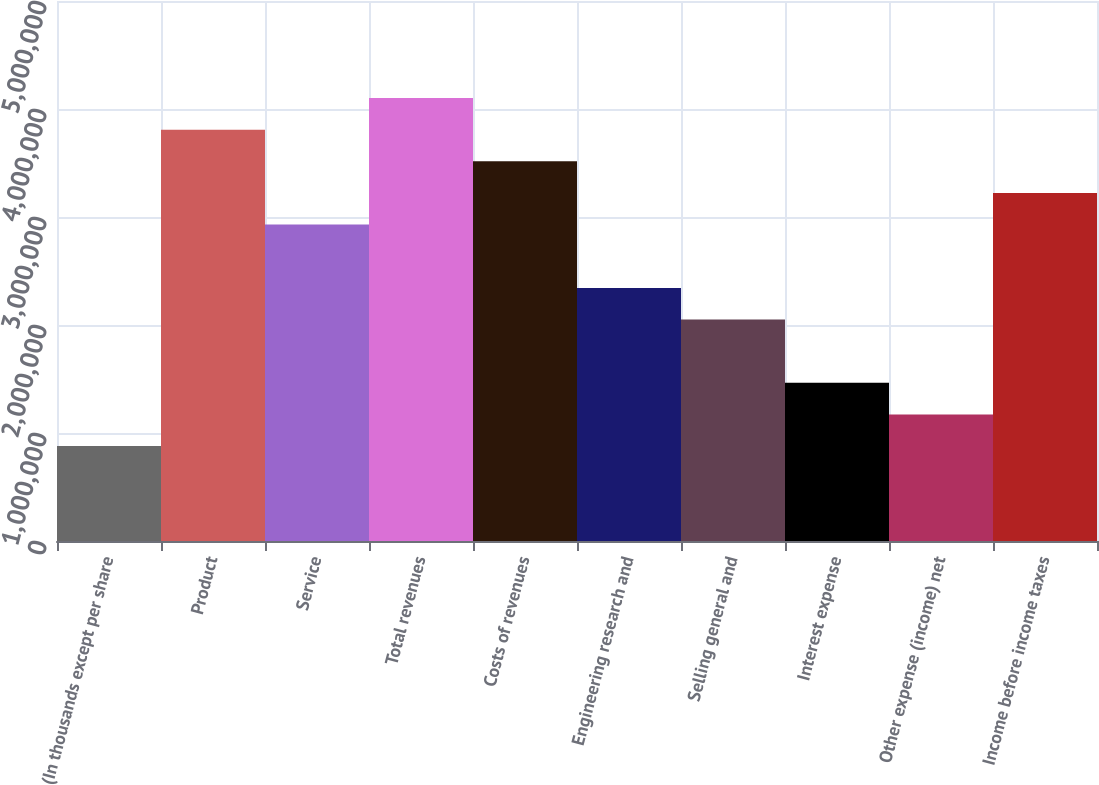<chart> <loc_0><loc_0><loc_500><loc_500><bar_chart><fcel>(In thousands except per share<fcel>Product<fcel>Service<fcel>Total revenues<fcel>Costs of revenues<fcel>Engineering research and<fcel>Selling general and<fcel>Interest expense<fcel>Other expense (income) net<fcel>Income before income taxes<nl><fcel>878824<fcel>3.80823e+06<fcel>2.92941e+06<fcel>4.10117e+06<fcel>3.51529e+06<fcel>2.34353e+06<fcel>2.05059e+06<fcel>1.4647e+06<fcel>1.17176e+06<fcel>3.22235e+06<nl></chart> 